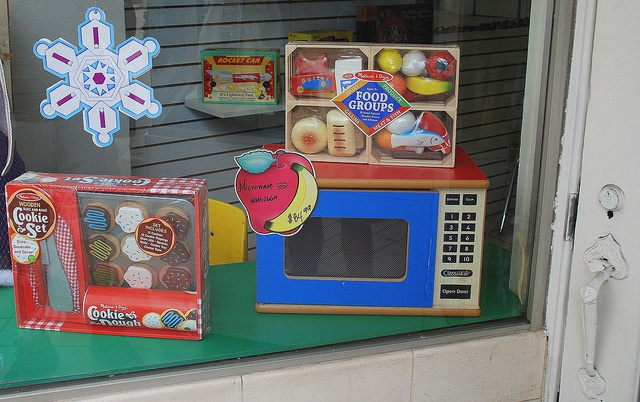Describe the objects in this image and their specific colors. I can see microwave in gray, blue, and black tones, apple in gray, brown, and teal tones, banana in gray, khaki, and tan tones, and banana in gray, olive, darkgreen, and gold tones in this image. 